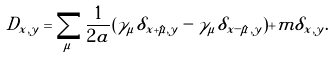Convert formula to latex. <formula><loc_0><loc_0><loc_500><loc_500>D _ { x , y } = \sum _ { \mu } \frac { 1 } { 2 a } ( \gamma _ { \mu } \delta _ { x + \hat { \mu } , y } - \gamma _ { \mu } \delta _ { x - \hat { \mu } , y } ) + m \delta _ { x , y } .</formula> 